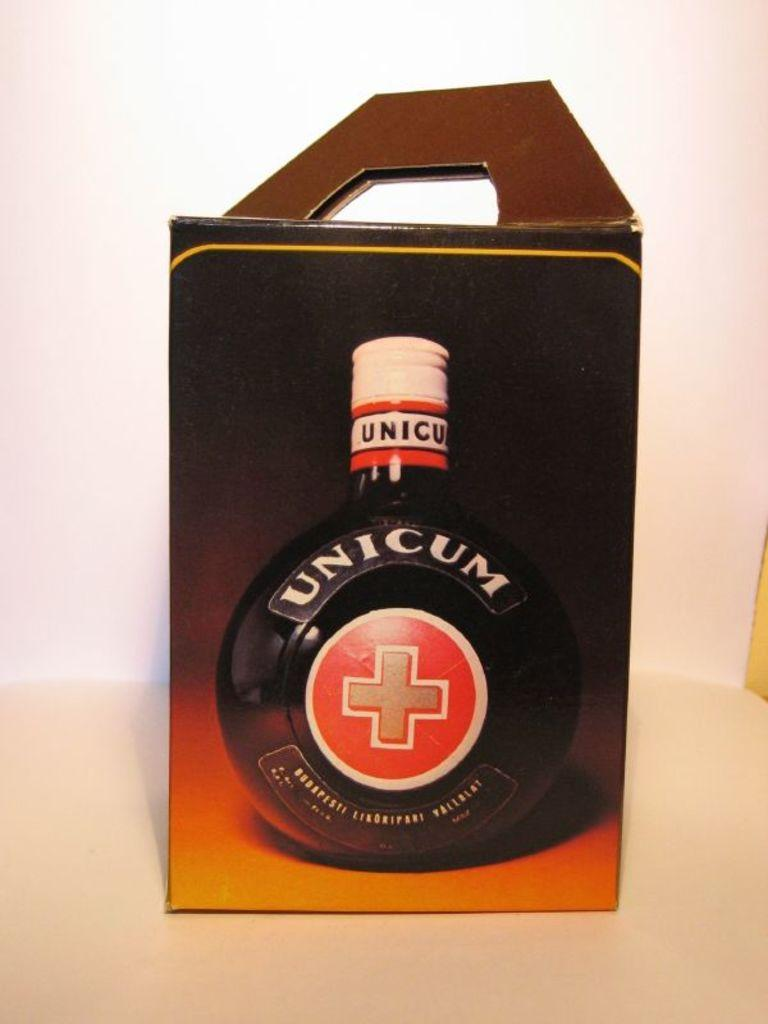<image>
Create a compact narrative representing the image presented. a box with a handle that has a picture of a bottle that says 'unicum' on it 